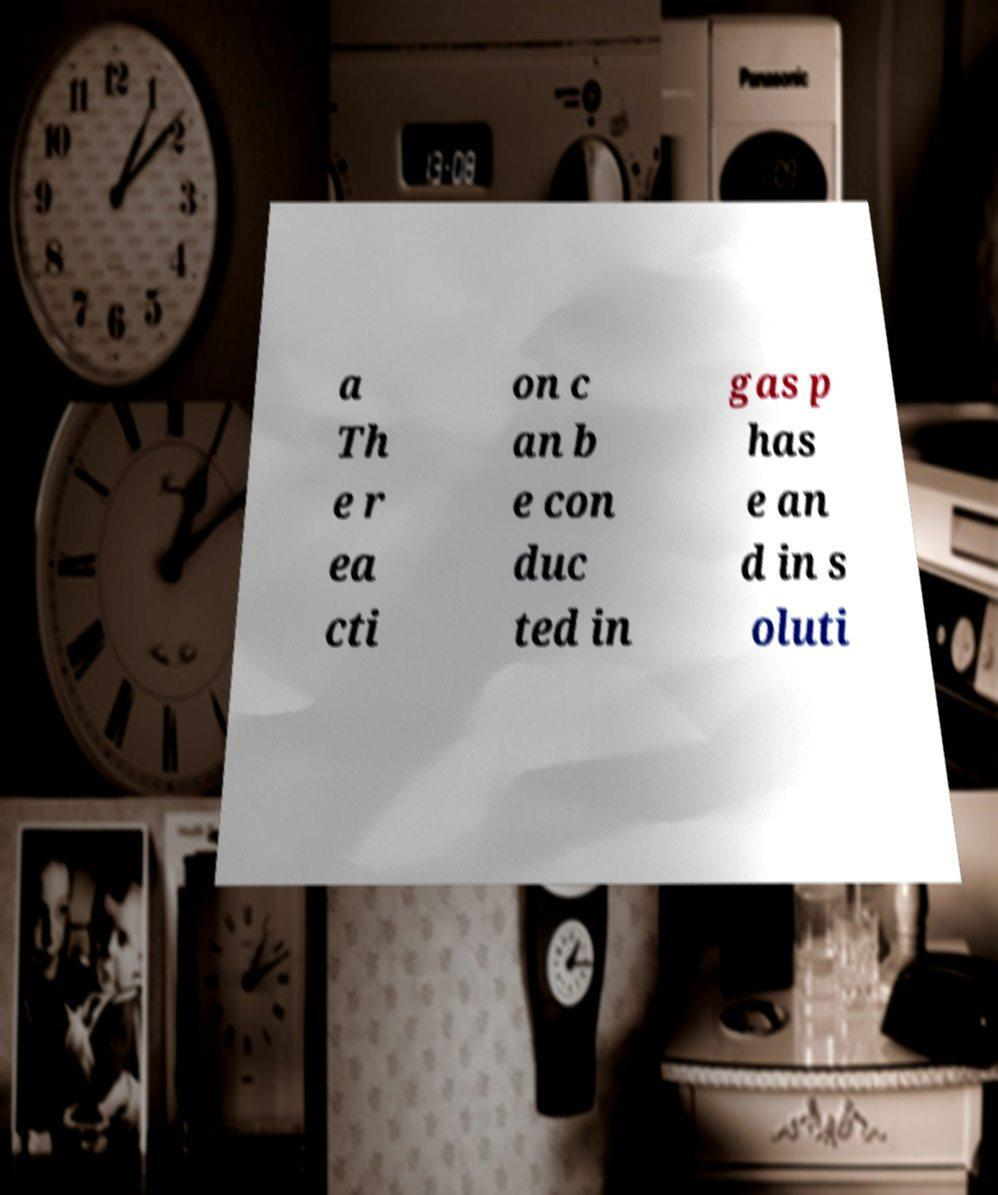Please identify and transcribe the text found in this image. a Th e r ea cti on c an b e con duc ted in gas p has e an d in s oluti 